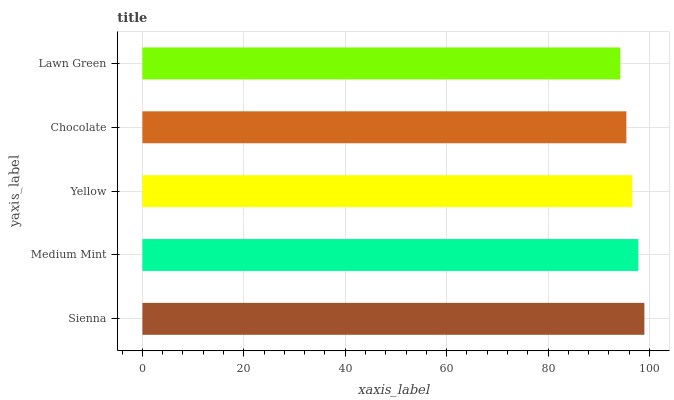Is Lawn Green the minimum?
Answer yes or no. Yes. Is Sienna the maximum?
Answer yes or no. Yes. Is Medium Mint the minimum?
Answer yes or no. No. Is Medium Mint the maximum?
Answer yes or no. No. Is Sienna greater than Medium Mint?
Answer yes or no. Yes. Is Medium Mint less than Sienna?
Answer yes or no. Yes. Is Medium Mint greater than Sienna?
Answer yes or no. No. Is Sienna less than Medium Mint?
Answer yes or no. No. Is Yellow the high median?
Answer yes or no. Yes. Is Yellow the low median?
Answer yes or no. Yes. Is Lawn Green the high median?
Answer yes or no. No. Is Chocolate the low median?
Answer yes or no. No. 